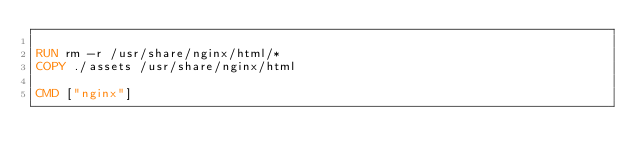<code> <loc_0><loc_0><loc_500><loc_500><_Dockerfile_>
RUN rm -r /usr/share/nginx/html/*
COPY ./assets /usr/share/nginx/html

CMD ["nginx"]</code> 